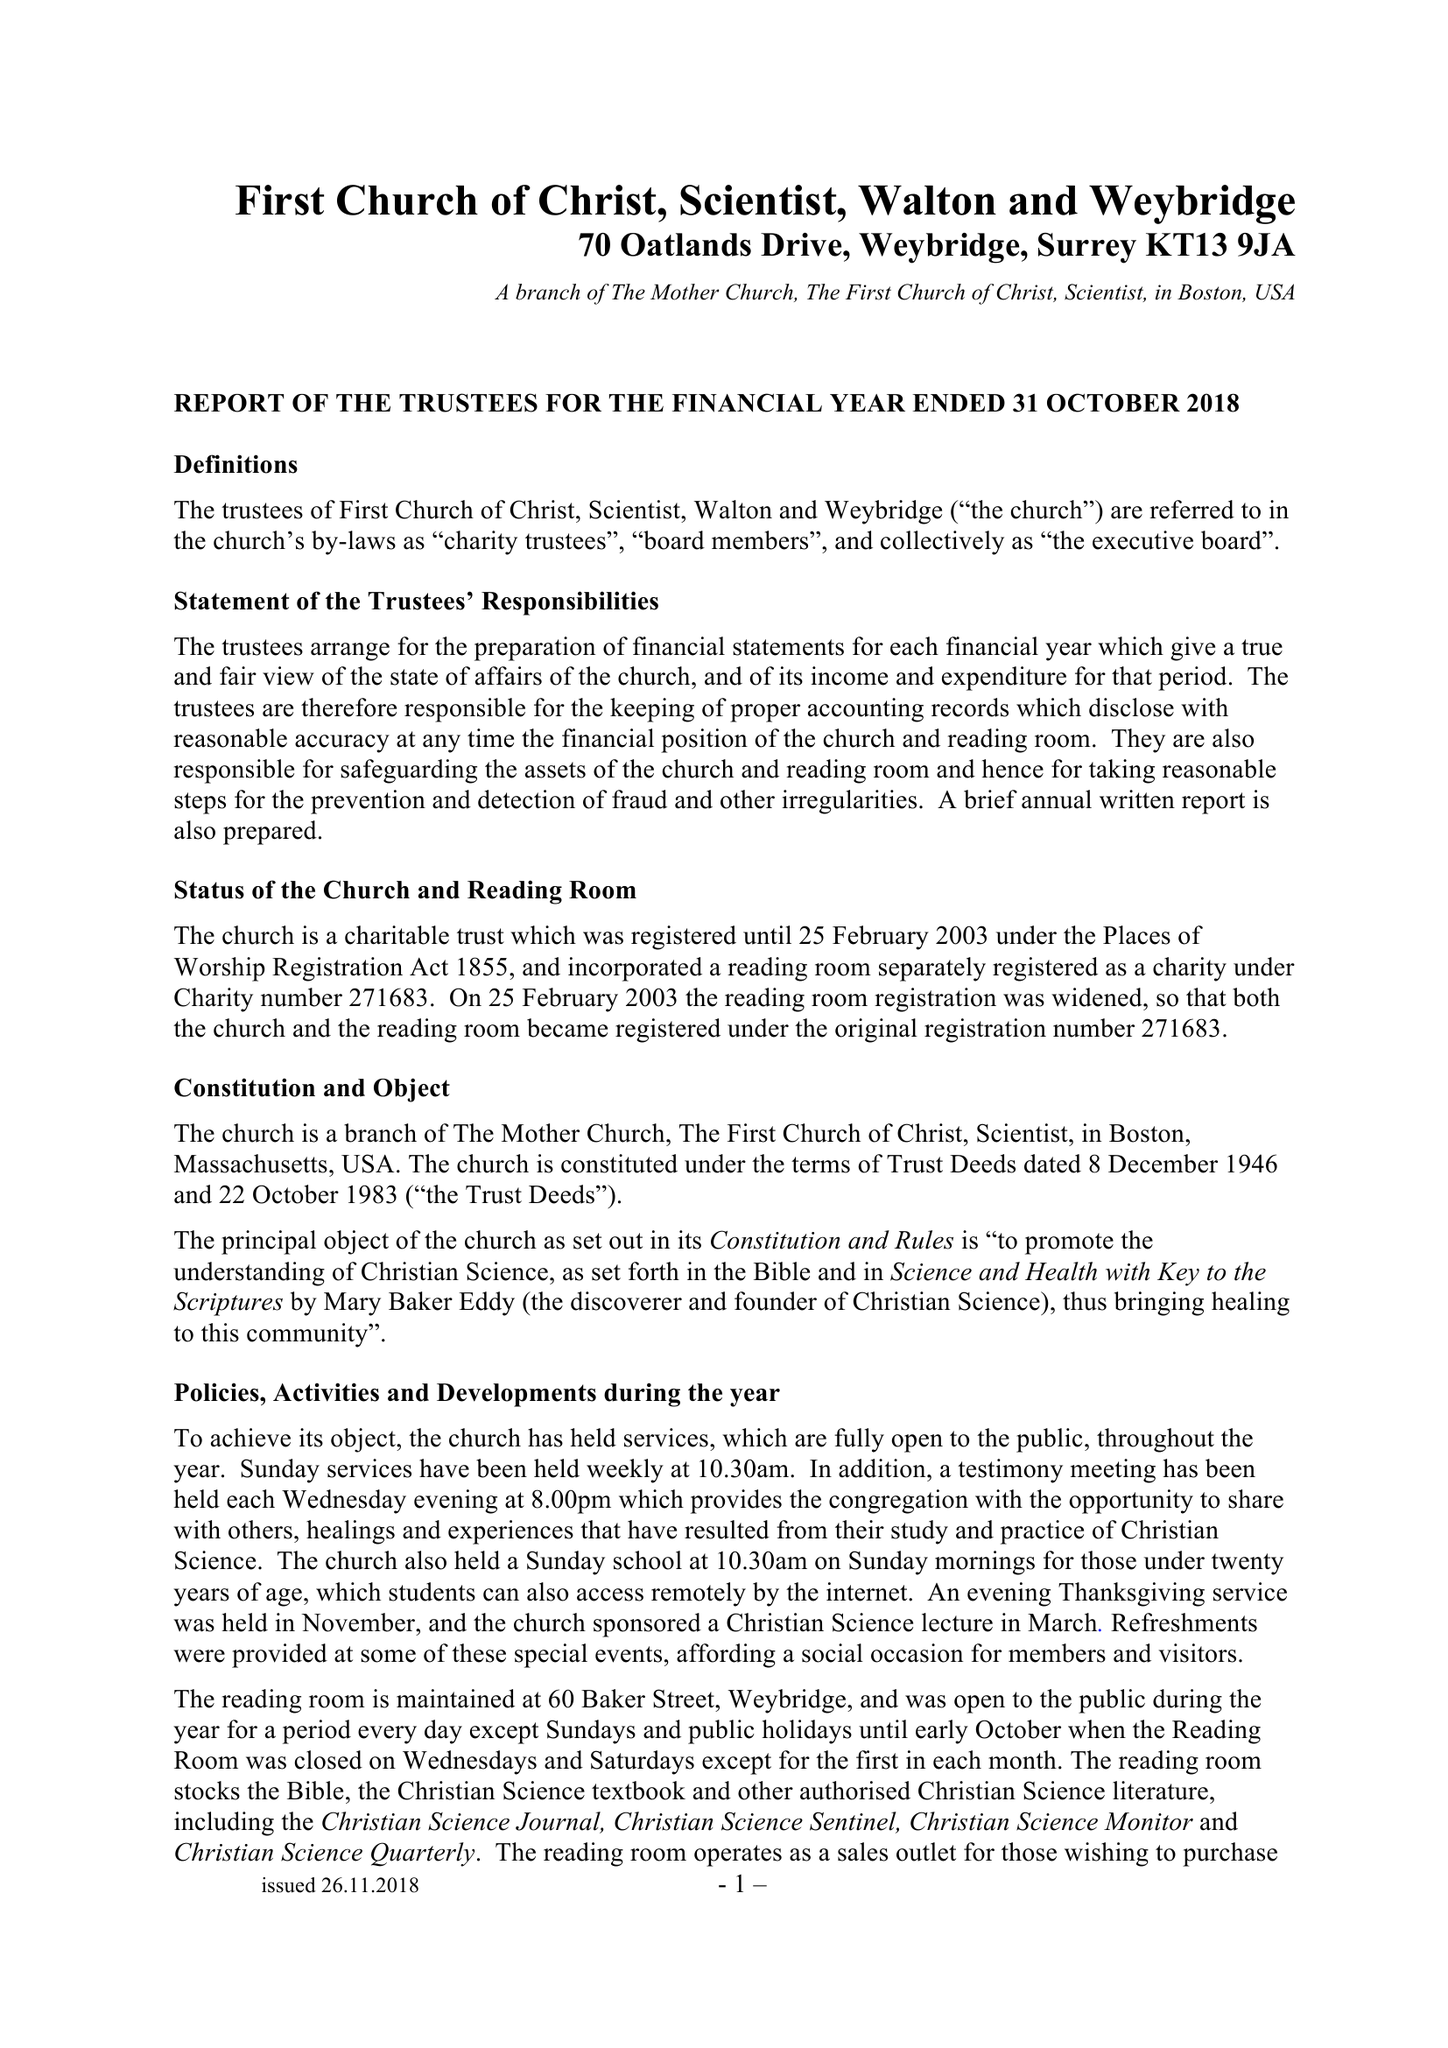What is the value for the spending_annually_in_british_pounds?
Answer the question using a single word or phrase. 47895.00 